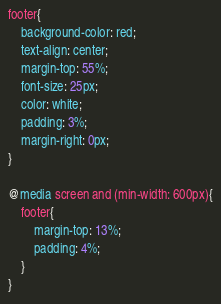Convert code to text. <code><loc_0><loc_0><loc_500><loc_500><_CSS_>footer{
    background-color: red;
    text-align: center;
    margin-top: 55%;
    font-size: 25px;
    color: white;
    padding: 3%;
    margin-right: 0px;
}

@media screen and (min-width: 600px){
    footer{
        margin-top: 13%;
        padding: 4%;
    }
}</code> 